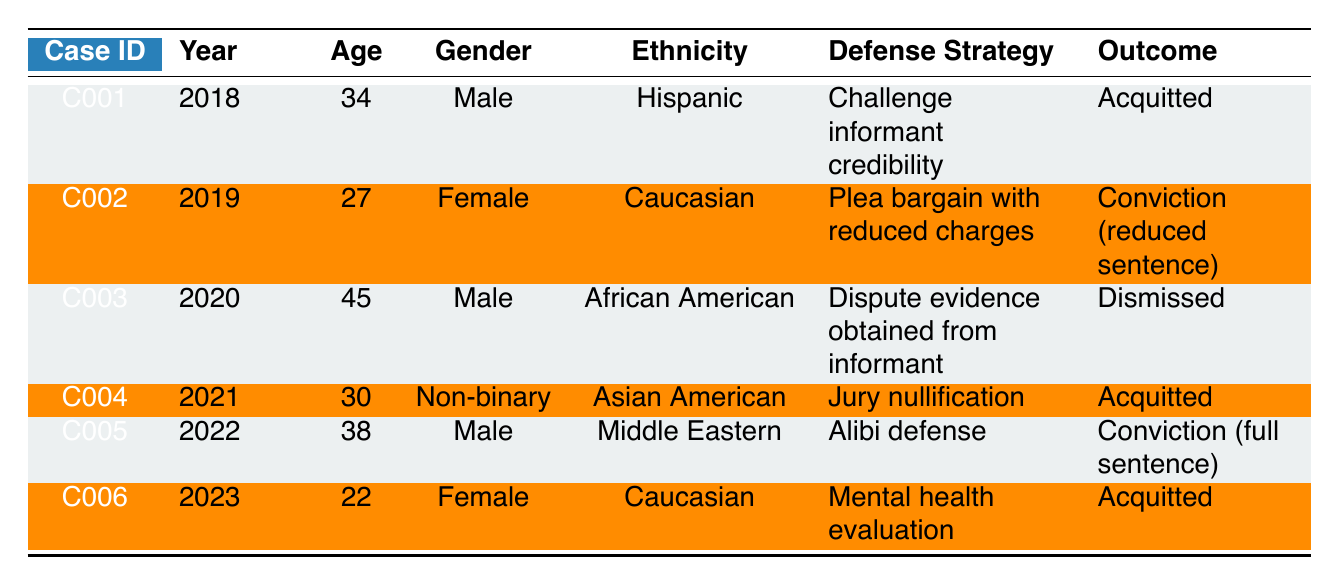What was the outcome of case C001? The table shows that case C001 resulted in an "Acquitted” outcome. This information is found in the "Outcome" column corresponding to row for case C001.
Answer: Acquitted How many cases ended with an acquittal? Looking at the “Outcome” column, there are three cases (C001, C004, C006) that ended with "Acquitted". This can be counted directly from the table.
Answer: 3 Which gender had a higher representation in the cases listed? By examining the "Gender" column, there are three males (C001, C003, C005), two females (C002, C006), and one non-binary individual (C004). Therefore, males have a higher representation.
Answer: Male What is the average age of the clients in these cases? The ages listed are 34, 27, 45, 30, 38, and 22. Adding these together gives 34 + 27 + 45 + 30 + 38 + 22 = 196. There are 6 cases, so the average age is 196 / 6 = approximately 32.67.
Answer: 32.67 Did any case result in a conviction? By examining the “Outcome” column, cases C002 and C005 resulted in a conviction. Therefore, the answer is yes, there are cases that resulted in a conviction.
Answer: Yes What was the defense strategy used in the oldest client case? The table shows that the oldest client is case C003 with an age of 45. In this case, the defense strategy used was to "Dispute evidence obtained from informant." This can be easily referenced in the "Defense Strategy" column of the table.
Answer: Dispute evidence obtained from informant How many cases involved Caucasian clients, and what was the outcome for those cases? There are two cases with Caucasian clients (C002 and C006). For C002, the outcome was "Conviction (reduced sentence)", and for C006, the outcome was "Acquitted". Therefore, the outcomes for these cases are one conviction and one acquittal.
Answer: 2 cases; outcomes: one conviction, one acquitted Which defense strategy was most common among the cases listed? By reviewing the "Defense Strategy" column: the strategies used were "Challenge informant credibility", "Plea bargain with reduced charges", "Dispute evidence obtained from informant", "Jury nullification", "Alibi defense", and "Mental health evaluation." Each strategy was used once, so no strategy is more common than the others. In this table, all strategies are unique.
Answer: None (all strategies unique) 